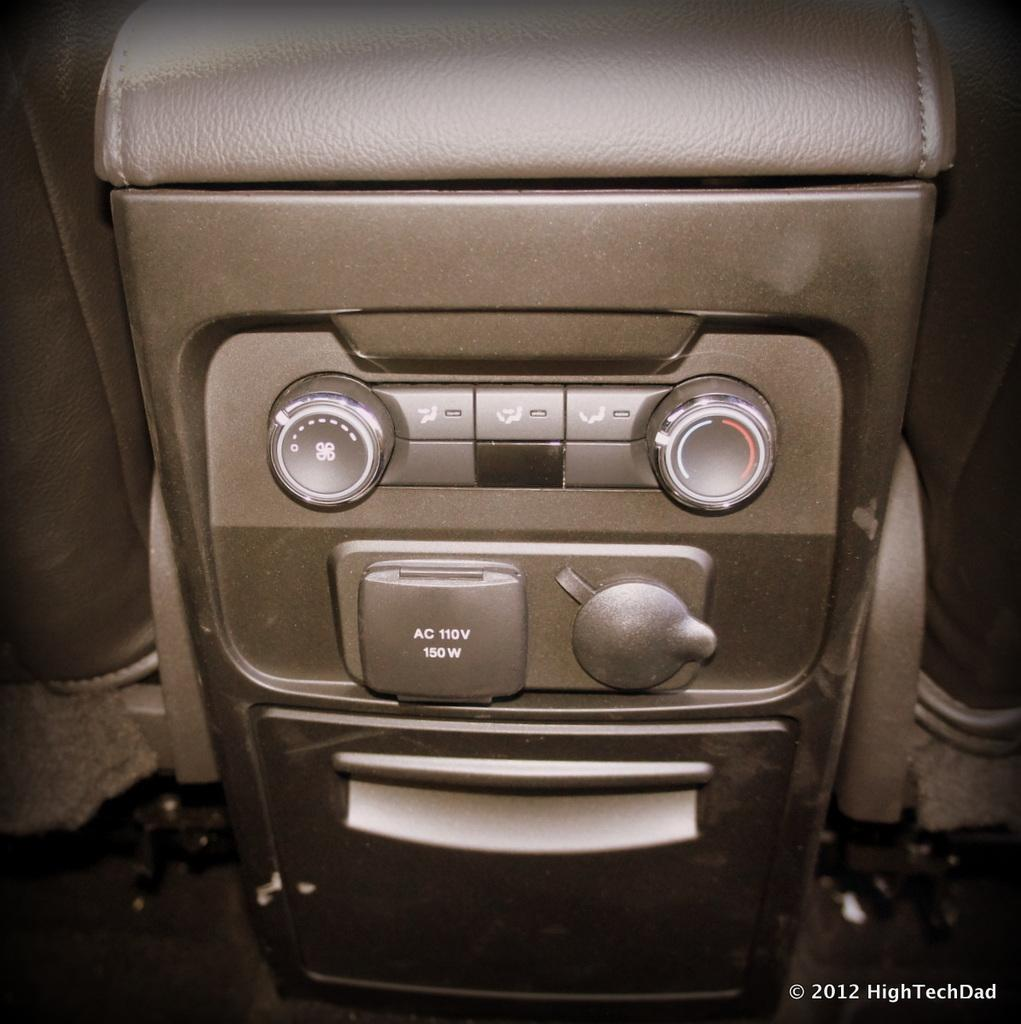What can be seen in the image that resembles a device? There is a device in the image. What feature does the device have? The device has buttons. What else is present in the image besides the device? There are objects in the image. Where can text be found in the image? Text can be found in the bottom right corner of the image. What type of ornament is hanging from the device in the image? There is no ornament hanging from the device in the image. What kind of plants can be seen growing near the device in the image? There are no plants visible in the image. 